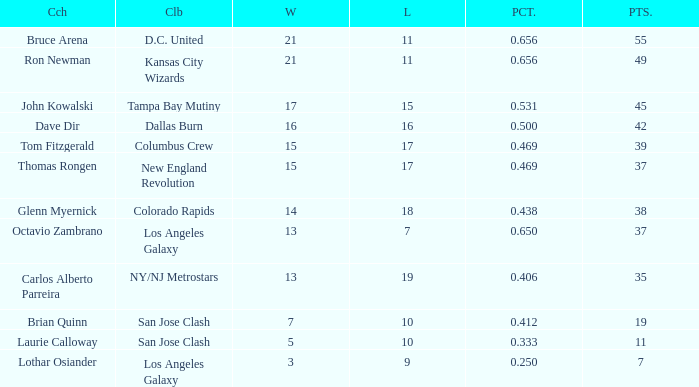What is the sum of points when Bruce Arena has 21 wins? 55.0. 